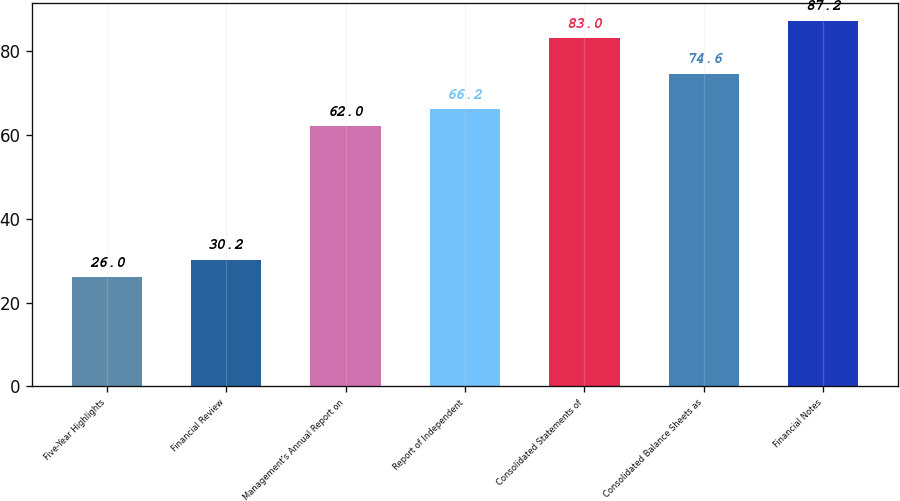Convert chart to OTSL. <chart><loc_0><loc_0><loc_500><loc_500><bar_chart><fcel>Five-Year Highlights<fcel>Financial Review<fcel>Management's Annual Report on<fcel>Report of Independent<fcel>Consolidated Statements of<fcel>Consolidated Balance Sheets as<fcel>Financial Notes<nl><fcel>26<fcel>30.2<fcel>62<fcel>66.2<fcel>83<fcel>74.6<fcel>87.2<nl></chart> 